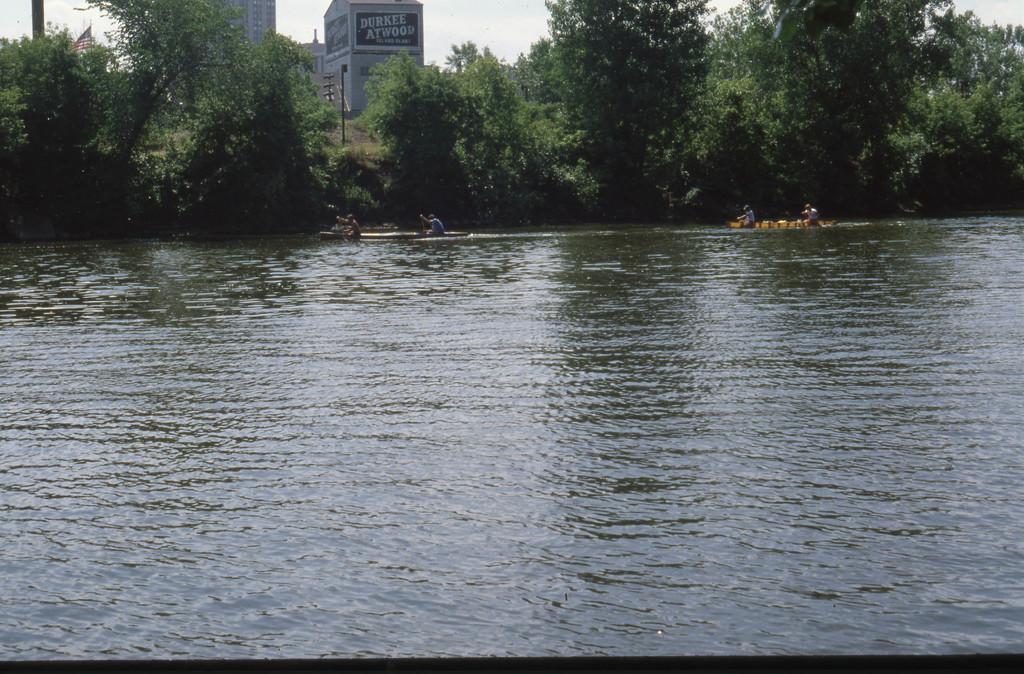How would you summarize this image in a sentence or two? In this picture there is water in the center of the image, on which there are boats, there are people those who are sitting on the boats and there are trees, posters, poles, and buildings in the background area of the image. 